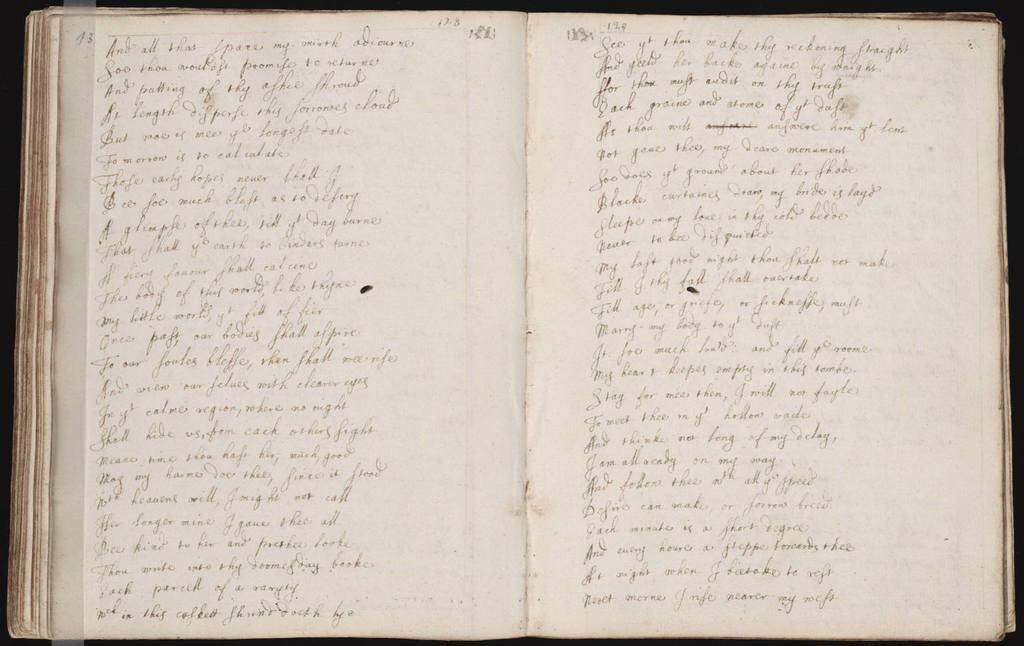<image>
Create a compact narrative representing the image presented. a book is shown open to page 13 